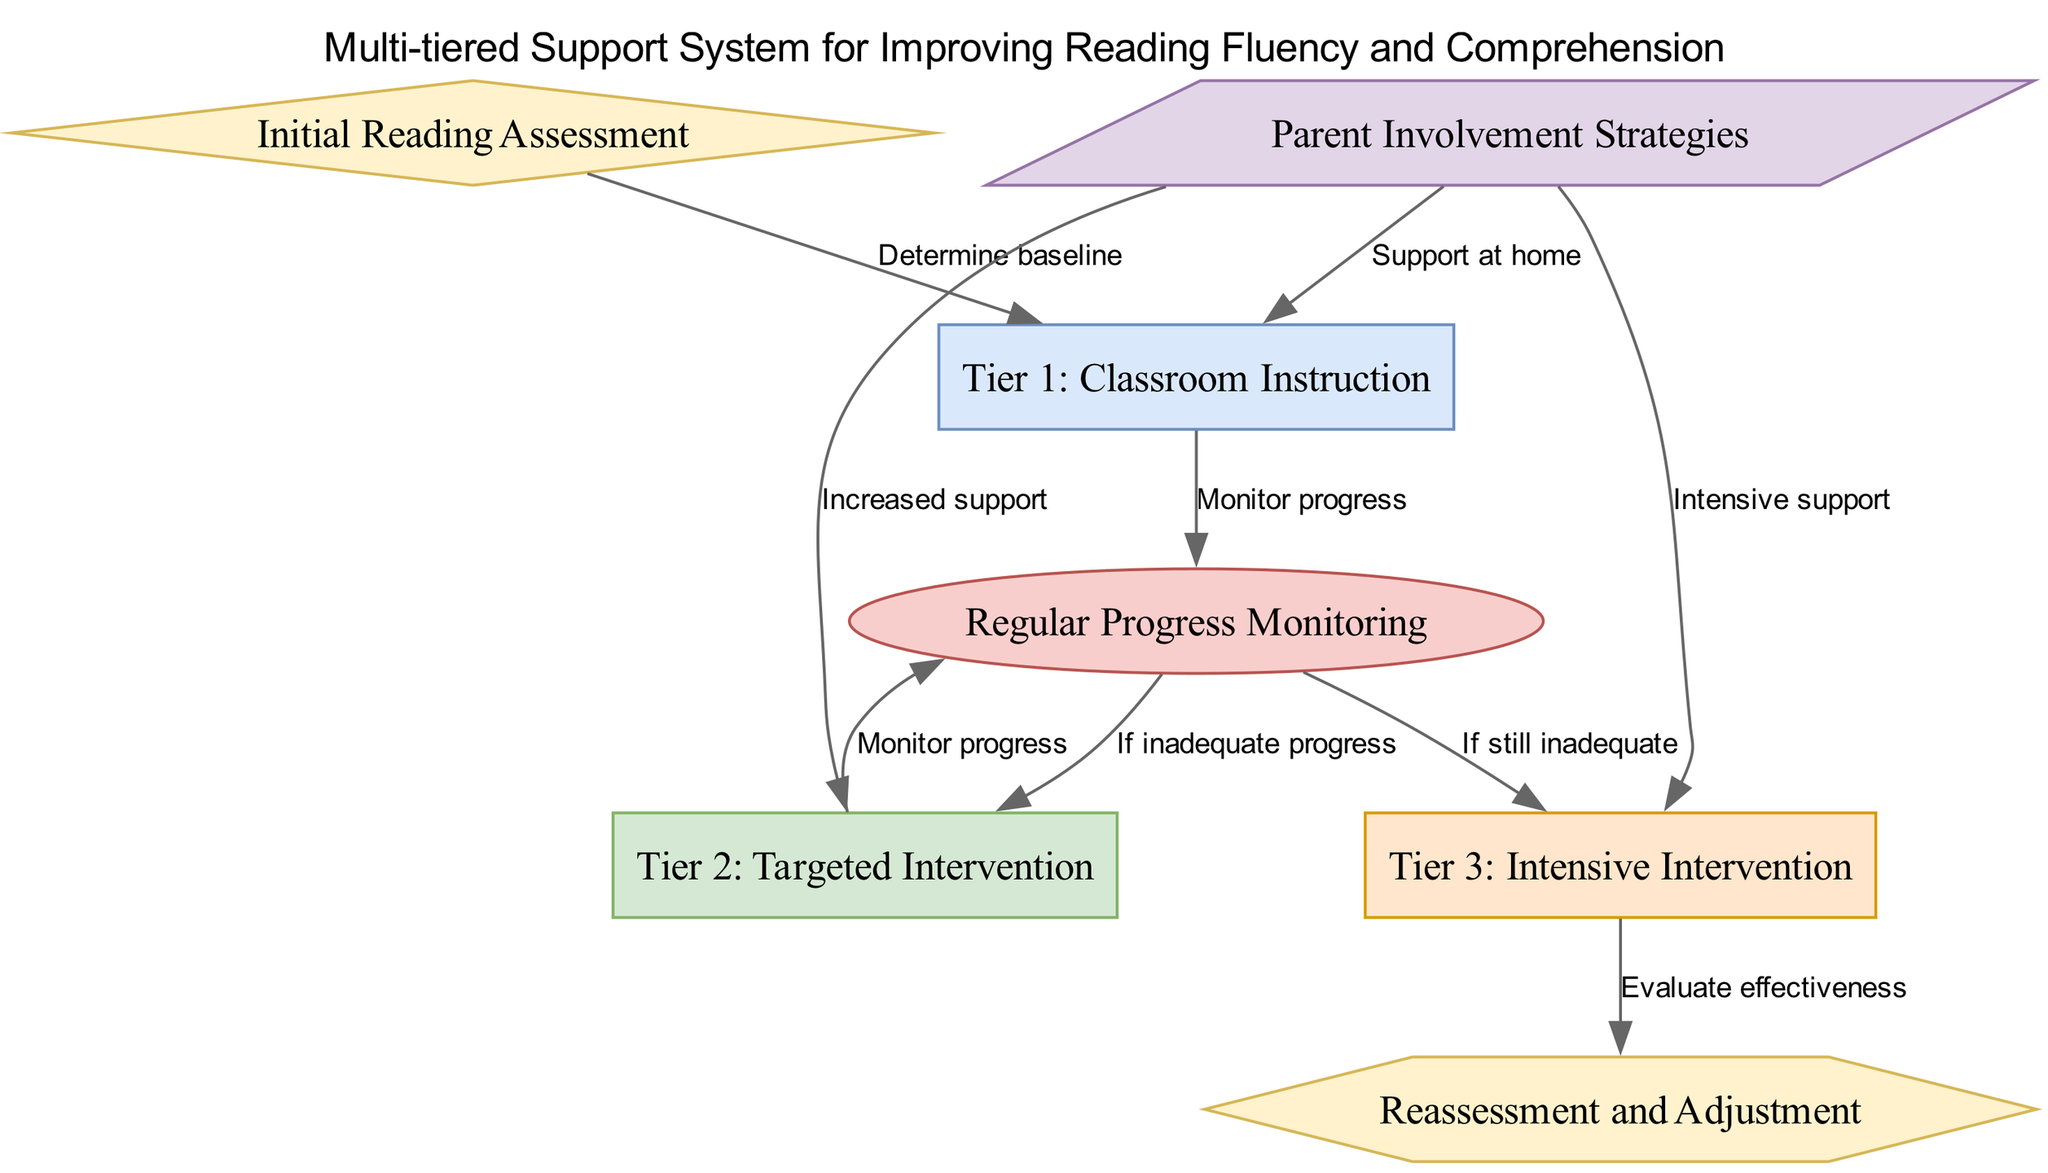What is the first step in the pathway? The diagram starts with the "Initial Reading Assessment," which is the first node coming into the pathway.
Answer: Initial Reading Assessment How many tiers of intervention are there? The diagram shows three tiers of interventions, specifically labeled as Tier 1, Tier 2, and Tier 3.
Answer: Three What happens after the initial assessment? Following the "Initial Reading Assessment," the next step is to "Determine baseline," leading to "Tier 1: Classroom Instruction."
Answer: Tier 1: Classroom Instruction What type of node is "Progress Monitoring"? "Progress Monitoring" is represented as an ellipse in the diagram, which indicates its type in the visual structure.
Answer: Ellipse What do we do if monitoring progress shows inadequate results after Tier 1? If there is inadequate progress after Tier 1, the pathway indicates we should proceed to "Tier 2: Targeted Intervention."
Answer: Tier 2: Targeted Intervention Which node relates to supporting reading strategies at home? The node "Parent Involvement Strategies" connects to multiple intervention tiers, highlighting the role of parents in the reading support process.
Answer: Parent Involvement Strategies What is evaluated after Tier 3? After Tier 3, the next step in the pathway is "Reassessment and Adjustment," which evaluates the effectiveness of the interventions used.
Answer: Reassessment and Adjustment If progress is inadequate after Tier 2, where do we go next? The pathway specifies that if progress remains inadequate after Tier 2, we should move to "Tier 3: Intensive Intervention."
Answer: Tier 3: Intensive Intervention What is the shape of "Initial Reading Assessment"? "Initial Reading Assessment" is represented as a diamond shape in the diagram, indicating its significance as the starting point.
Answer: Diamond 